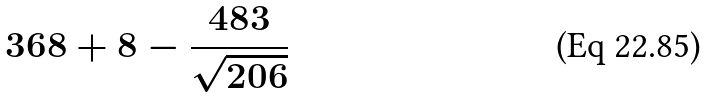Convert formula to latex. <formula><loc_0><loc_0><loc_500><loc_500>3 6 8 + 8 - \frac { 4 8 3 } { \sqrt { 2 0 6 } }</formula> 